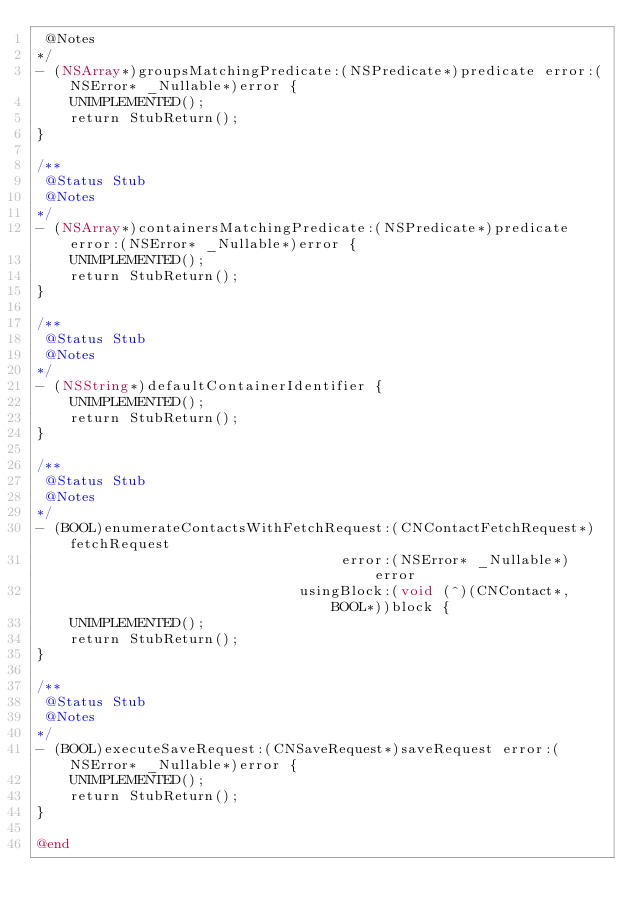<code> <loc_0><loc_0><loc_500><loc_500><_ObjectiveC_> @Notes
*/
- (NSArray*)groupsMatchingPredicate:(NSPredicate*)predicate error:(NSError* _Nullable*)error {
    UNIMPLEMENTED();
    return StubReturn();
}

/**
 @Status Stub
 @Notes
*/
- (NSArray*)containersMatchingPredicate:(NSPredicate*)predicate error:(NSError* _Nullable*)error {
    UNIMPLEMENTED();
    return StubReturn();
}

/**
 @Status Stub
 @Notes
*/
- (NSString*)defaultContainerIdentifier {
    UNIMPLEMENTED();
    return StubReturn();
}

/**
 @Status Stub
 @Notes
*/
- (BOOL)enumerateContactsWithFetchRequest:(CNContactFetchRequest*)fetchRequest
                                    error:(NSError* _Nullable*)error
                               usingBlock:(void (^)(CNContact*, BOOL*))block {
    UNIMPLEMENTED();
    return StubReturn();
}

/**
 @Status Stub
 @Notes
*/
- (BOOL)executeSaveRequest:(CNSaveRequest*)saveRequest error:(NSError* _Nullable*)error {
    UNIMPLEMENTED();
    return StubReturn();
}

@end
</code> 